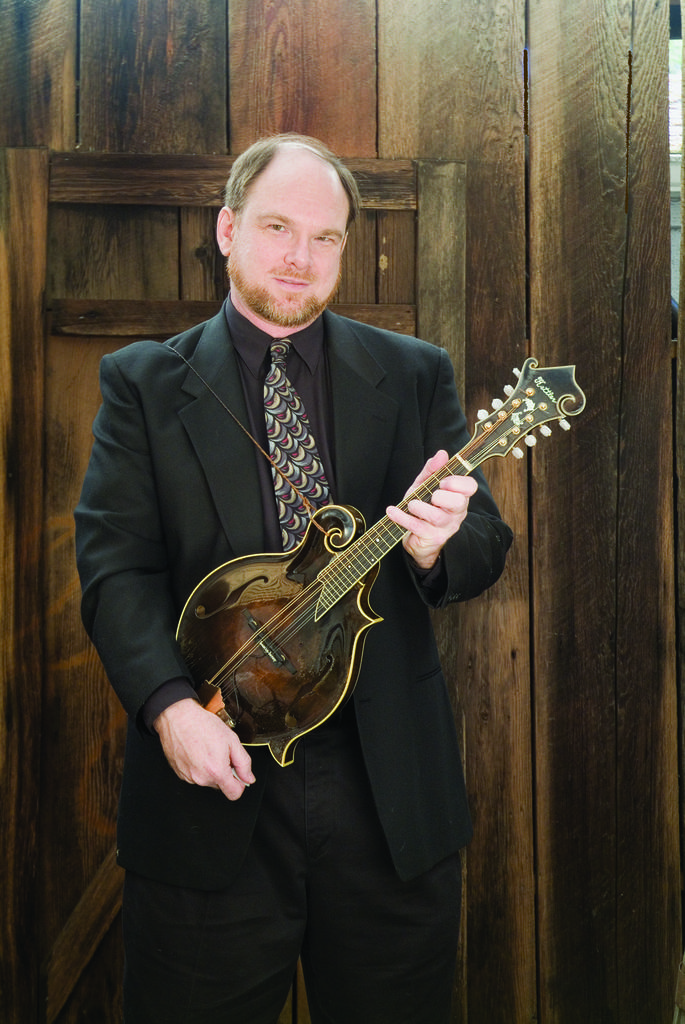What is the main subject of the image? The main subject of the image is a man. What is the man holding in his hand? The man is holding a guitar in his hand. How does the man compare to an insect in the image? The image does not include any insects for comparison. What type of glue is the man using to hold the guitar in the image? There is no glue present in the image; the man is simply holding the guitar with his hand. 